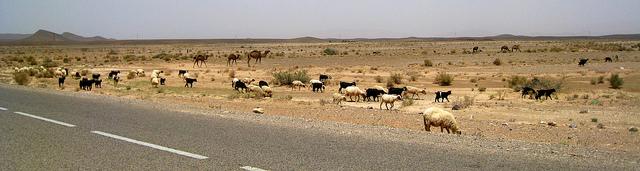Are these animals in a fence?
Write a very short answer. No. What types of animals are visible?
Write a very short answer. Cows. Are there any people?
Be succinct. No. 